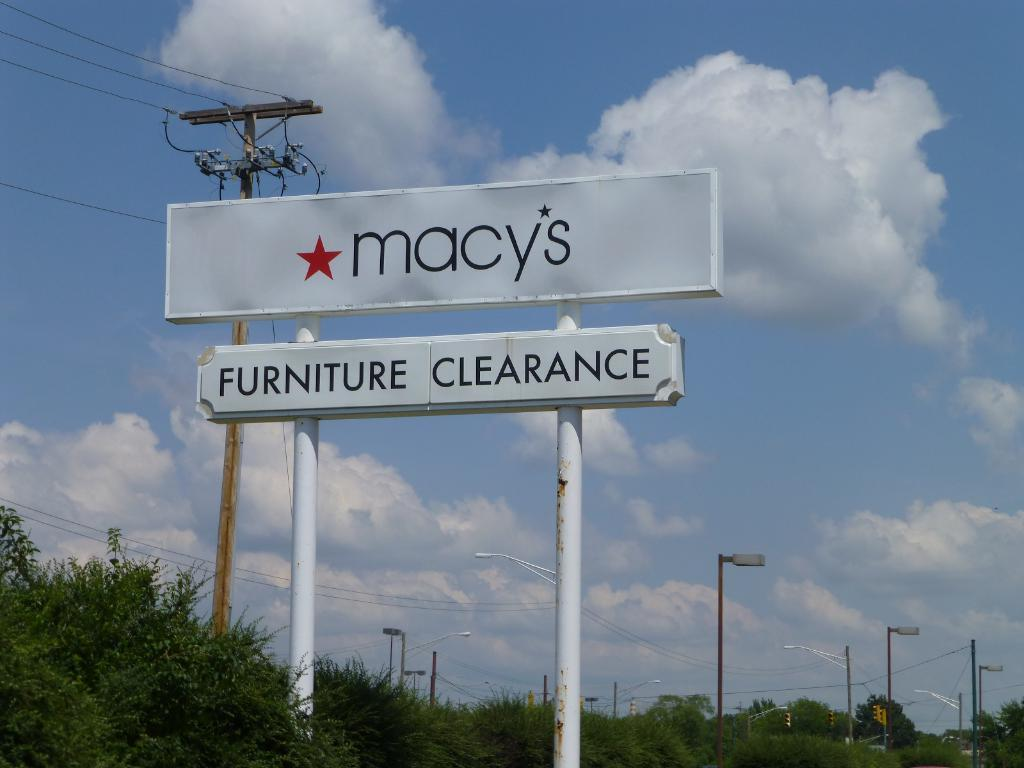<image>
Give a short and clear explanation of the subsequent image. A sign for Macy's furniture clearance rises up by some electric poles. 